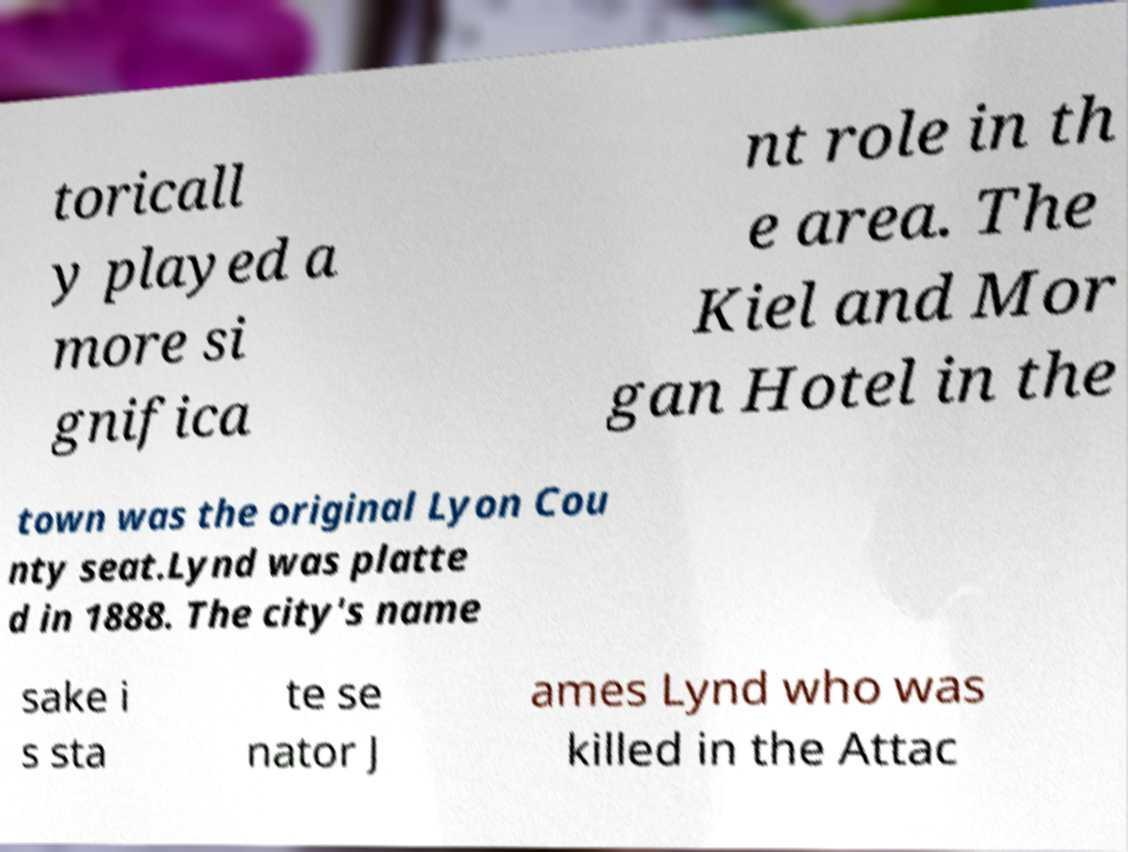What messages or text are displayed in this image? I need them in a readable, typed format. toricall y played a more si gnifica nt role in th e area. The Kiel and Mor gan Hotel in the town was the original Lyon Cou nty seat.Lynd was platte d in 1888. The city's name sake i s sta te se nator J ames Lynd who was killed in the Attac 